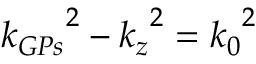Convert formula to latex. <formula><loc_0><loc_0><loc_500><loc_500>{ k _ { G P s } } ^ { 2 } - { k _ { z } } ^ { 2 } = { k _ { 0 } } ^ { 2 }</formula> 